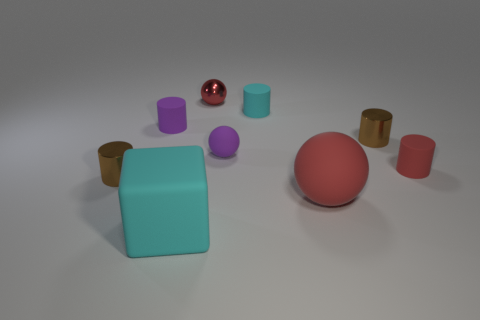How many objects are either small rubber objects on the left side of the big block or purple cylinders? Upon examining the image, there is one small, pink rubber ball that lies to the left side of the large turquoise block. Additionally, there are two purple cylinders in the scene. In total, there are three objects that meet the criteria - one small rubber object on the left side of the big block and two purple cylinders. 